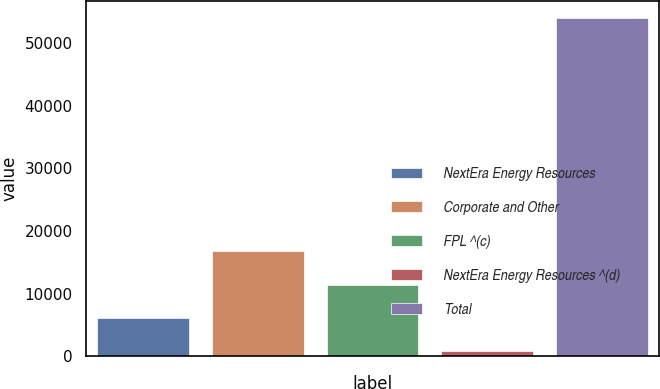Convert chart to OTSL. <chart><loc_0><loc_0><loc_500><loc_500><bar_chart><fcel>NextEra Energy Resources<fcel>Corporate and Other<fcel>FPL ^(c)<fcel>NextEra Energy Resources ^(d)<fcel>Total<nl><fcel>6114.8<fcel>16754.4<fcel>11434.6<fcel>795<fcel>53993<nl></chart> 